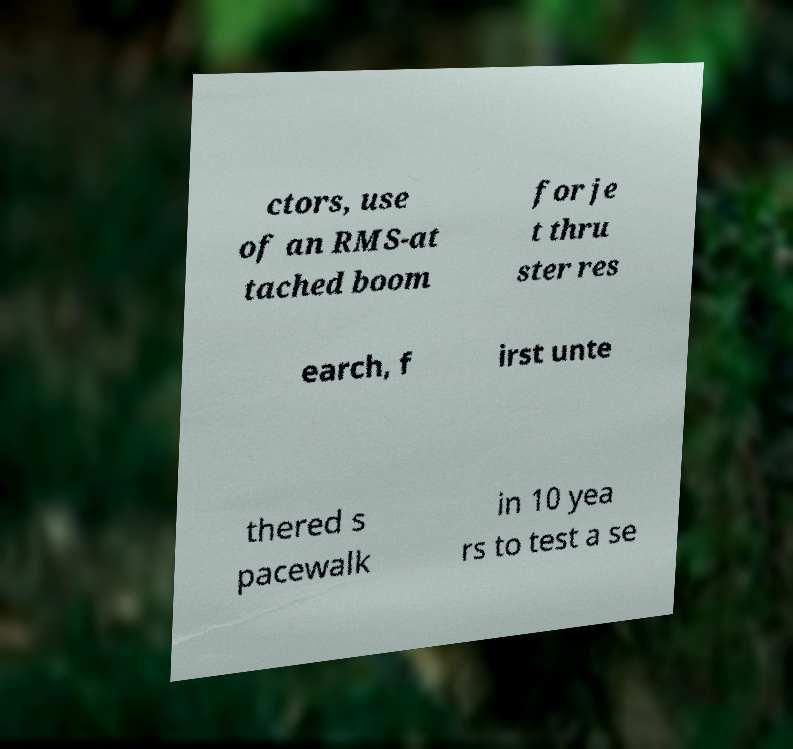Can you accurately transcribe the text from the provided image for me? ctors, use of an RMS-at tached boom for je t thru ster res earch, f irst unte thered s pacewalk in 10 yea rs to test a se 